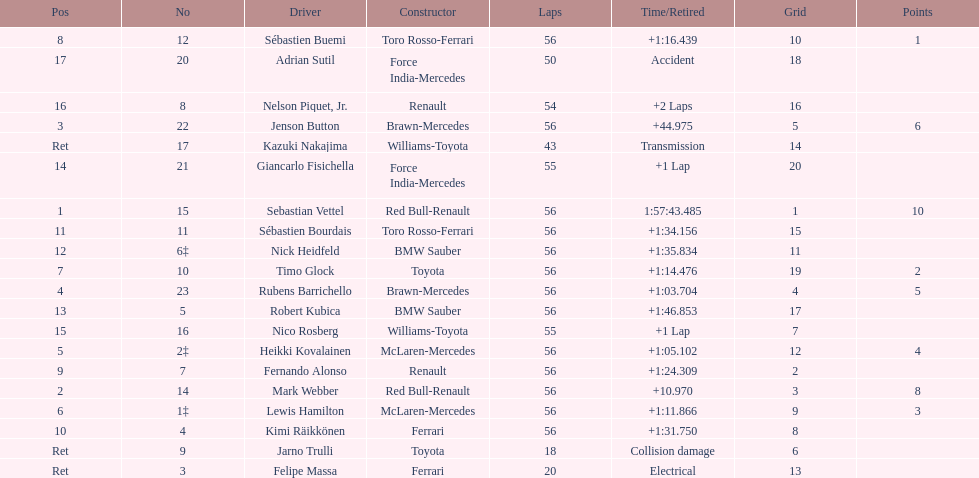What name is just previous to kazuki nakjima on the list? Adrian Sutil. 